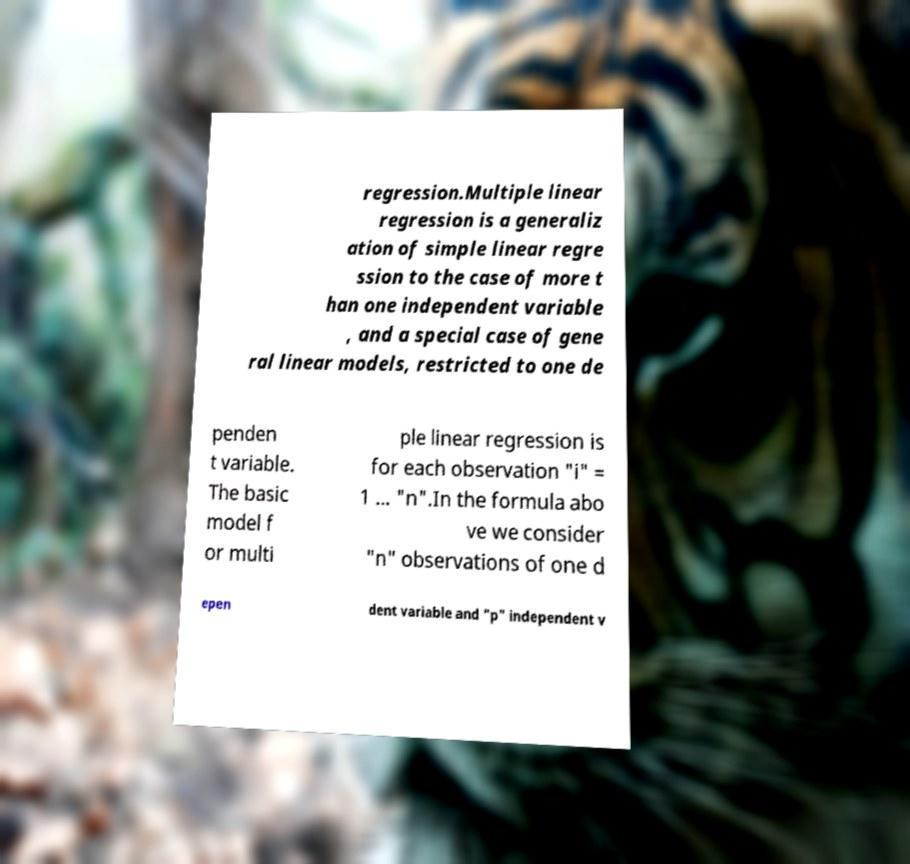I need the written content from this picture converted into text. Can you do that? regression.Multiple linear regression is a generaliz ation of simple linear regre ssion to the case of more t han one independent variable , and a special case of gene ral linear models, restricted to one de penden t variable. The basic model f or multi ple linear regression is for each observation "i" = 1 ... "n".In the formula abo ve we consider "n" observations of one d epen dent variable and "p" independent v 